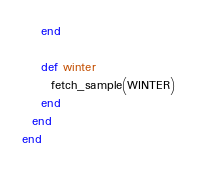<code> <loc_0><loc_0><loc_500><loc_500><_Ruby_>    end

    def winter
      fetch_sample(WINTER)
    end
  end
end
</code> 